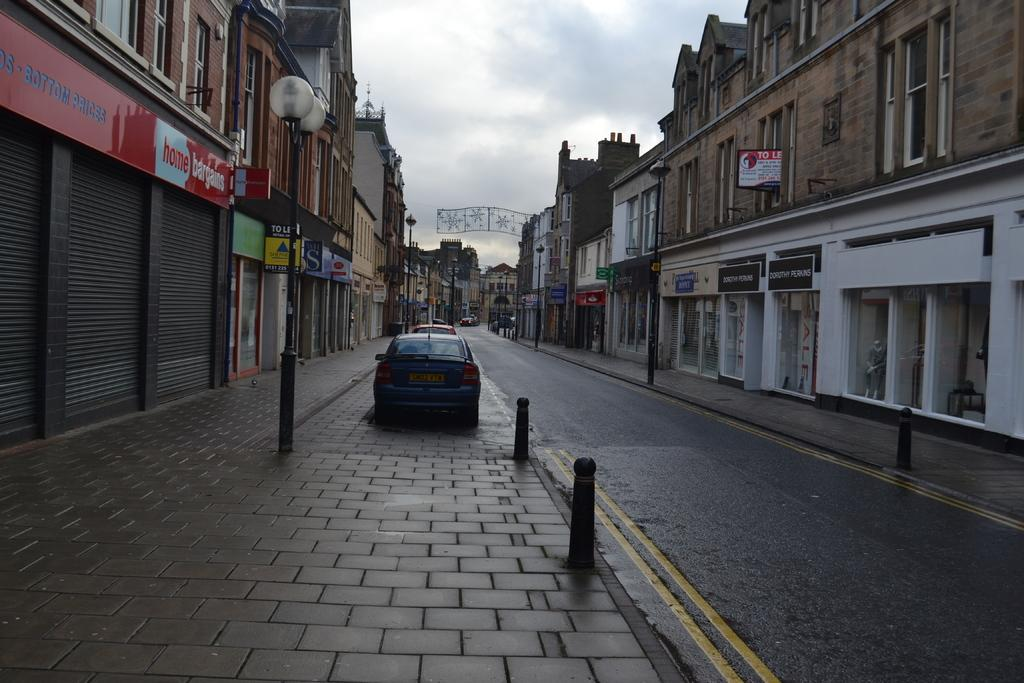What types of objects can be seen in the image? There are vehicles, buildings, lights, poles, boards, and roller shutters in the image. Can you describe the setting of the image? The image features a combination of urban elements such as buildings, lights, and roller shutters, as well as infrastructure elements like poles and boards. What is visible in the background of the image? The sky is visible in the background of the image. How many potatoes can be seen on the boards in the image? There are no potatoes visible on the boards in the image. What type of insect can be seen interacting with the lights in the image? There are no insects visible interacting with the lights in the image. 